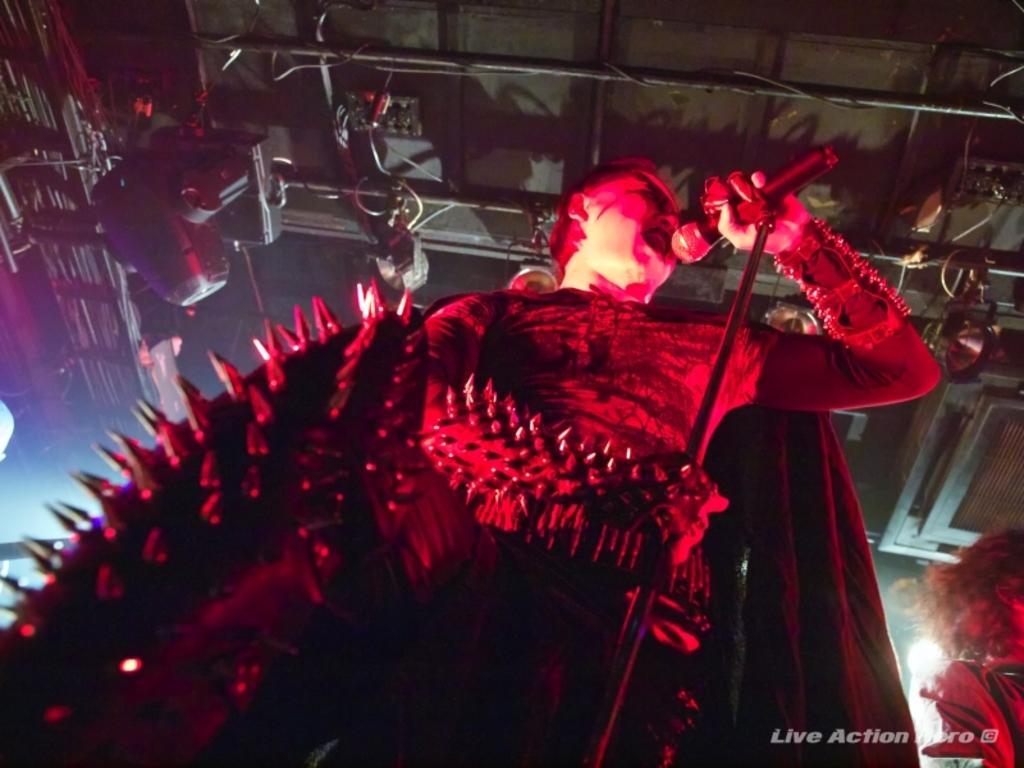In one or two sentences, can you explain what this image depicts? In this picture we can see a person in the fancy dress and the man is holding a microphone and a stand. On the right side of the person there is another person is standing. At the top there are lights and iron rods. On the image there is a watermark. 